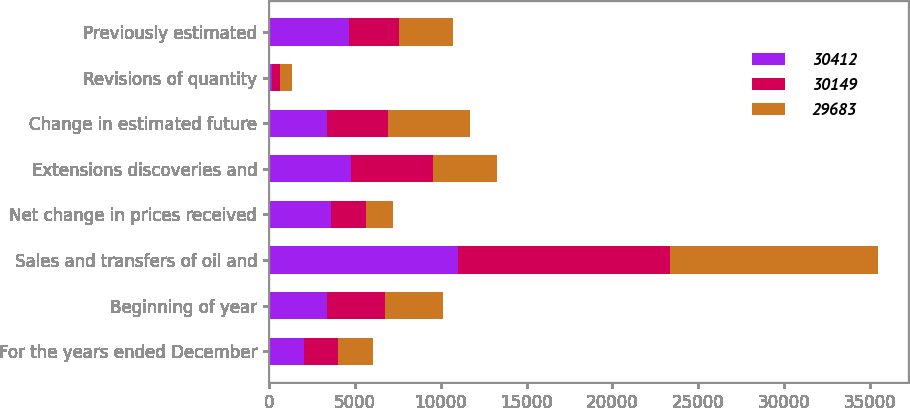<chart> <loc_0><loc_0><loc_500><loc_500><stacked_bar_chart><ecel><fcel>For the years ended December<fcel>Beginning of year<fcel>Sales and transfers of oil and<fcel>Net change in prices received<fcel>Extensions discoveries and<fcel>Change in estimated future<fcel>Revisions of quantity<fcel>Previously estimated<nl><fcel>30412<fcel>2014<fcel>3375<fcel>11016<fcel>3641<fcel>4754<fcel>3375<fcel>190<fcel>4676<nl><fcel>30149<fcel>2013<fcel>3375<fcel>12324<fcel>2000<fcel>4792<fcel>3546<fcel>475<fcel>2926<nl><fcel>29683<fcel>2012<fcel>3375<fcel>12124<fcel>1590<fcel>3728<fcel>4769<fcel>653<fcel>3143<nl></chart> 